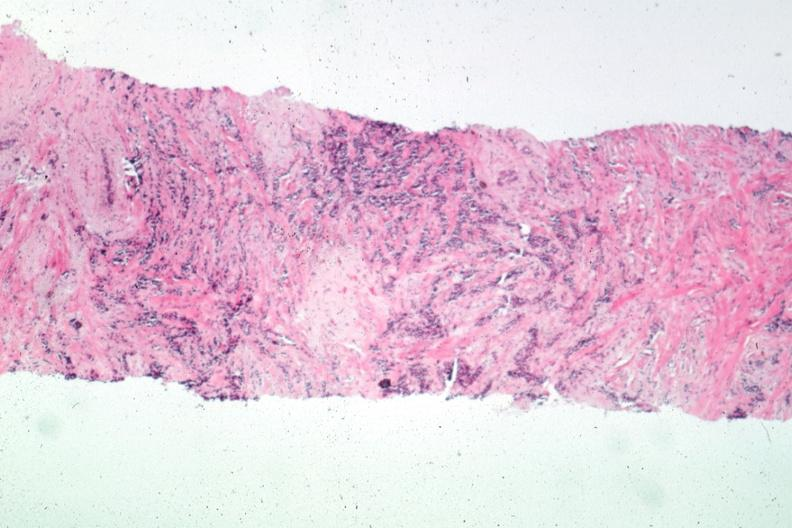where is this area in the body?
Answer the question using a single word or phrase. Breast 